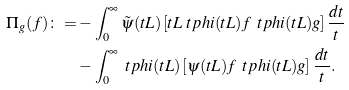<formula> <loc_0><loc_0><loc_500><loc_500>\Pi _ { g } ( f ) \colon = & - \int _ { 0 } ^ { \infty } \tilde { \psi } ( t L ) \left [ t L \ t p h i ( t L ) f \, \ t p h i ( t L ) g \right ] \frac { d t } { t } \\ & - \int _ { 0 } ^ { \infty } \ t p h i ( t L ) \left [ \psi ( t L ) f \, \ t p h i ( t L ) g \right ] \frac { d t } { t } .</formula> 